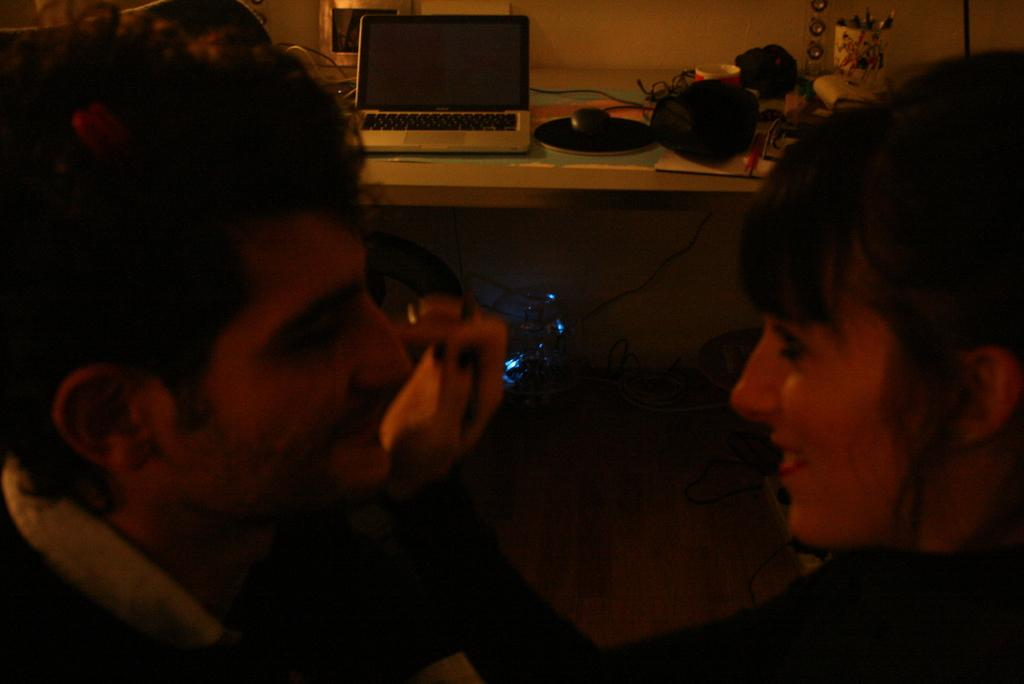Who is present in the image? There is a man and a woman in the image. What are the facial expressions of the people in the image? Both the man and the woman are smiling in the image. What electronic device can be seen in the image? There is a laptop in the image. What is on the table in the image? There are objects on a table in the image. What can be seen illuminating the scene in the image? There are lights visible in the image. What is in the background of the image? There is a wall in the background of the image. What is the purpose of the copper toothbrush in the image? There is no copper toothbrush present in the image. 